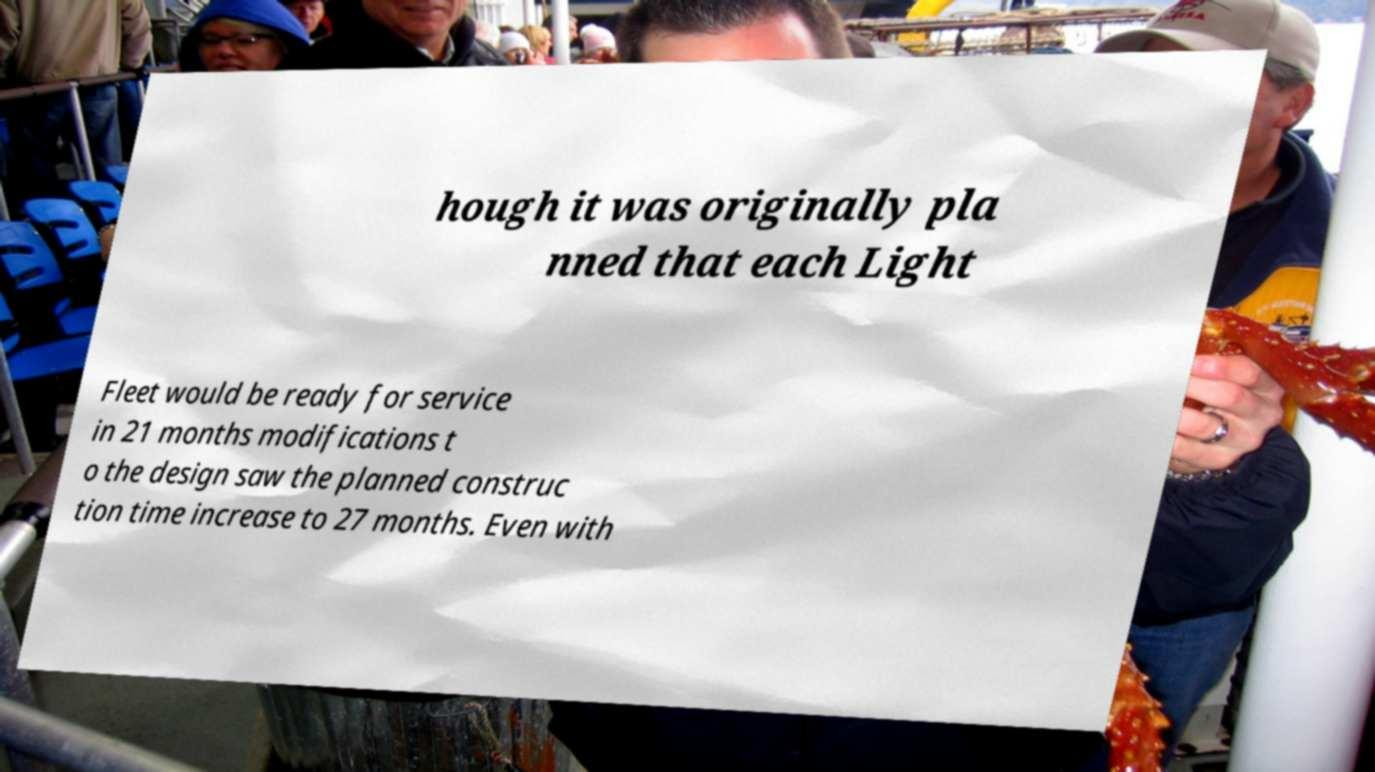Can you accurately transcribe the text from the provided image for me? hough it was originally pla nned that each Light Fleet would be ready for service in 21 months modifications t o the design saw the planned construc tion time increase to 27 months. Even with 